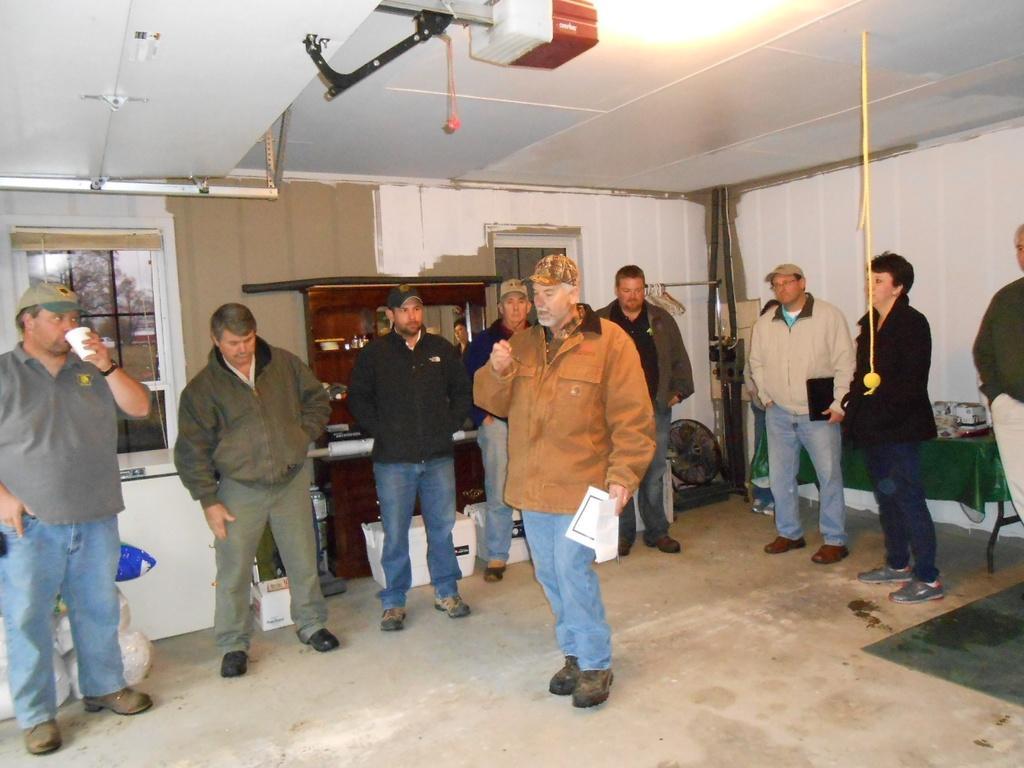Could you give a brief overview of what you see in this image? In this image we can see a group of people standing on the floor. One person is holding a glass in his hand. One person is holding a paper in his hand. In the background, we can see a table fan placed on the ground, some object placed on the table, mirror, windows, a device placed on stand, tree and the sky. 